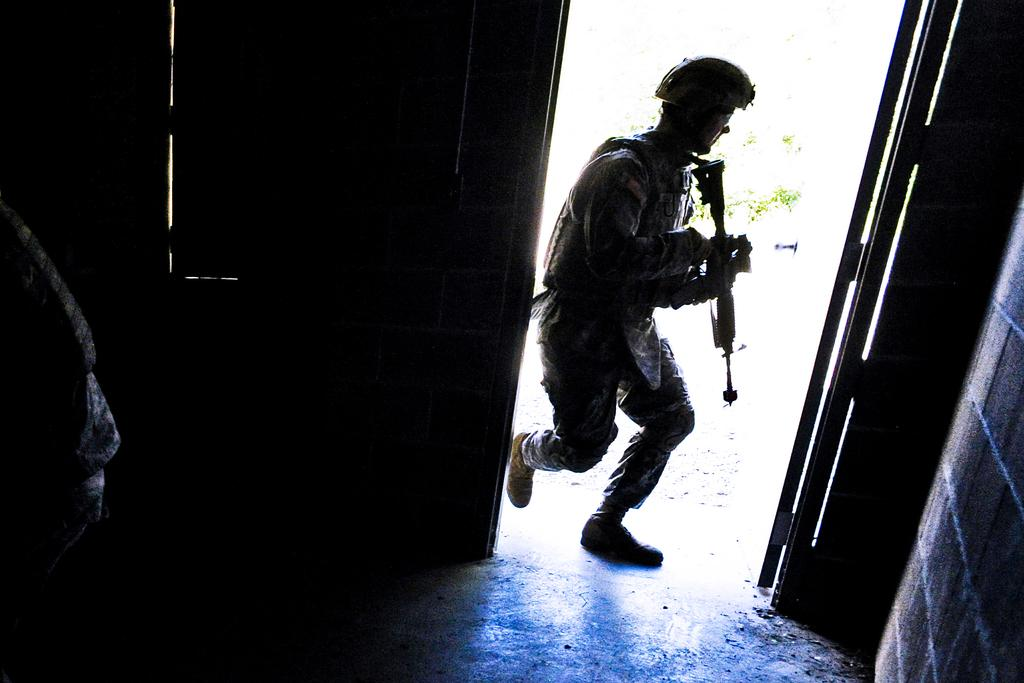What can be seen in the image? There is a person in the image. What is the person holding in their hand? The person is holding a gun in their hand. What type of protective gear is the person wearing? The person is wearing a helmet. What is visible on the right side of the image? There is a wall on the right side of the image. What type of marble is being used to build the ship in the image? There is no ship or marble present in the image. Can you tell me how many zippers are visible on the person's clothing in the image? There is no mention of zippers on the person's clothing in the image. 